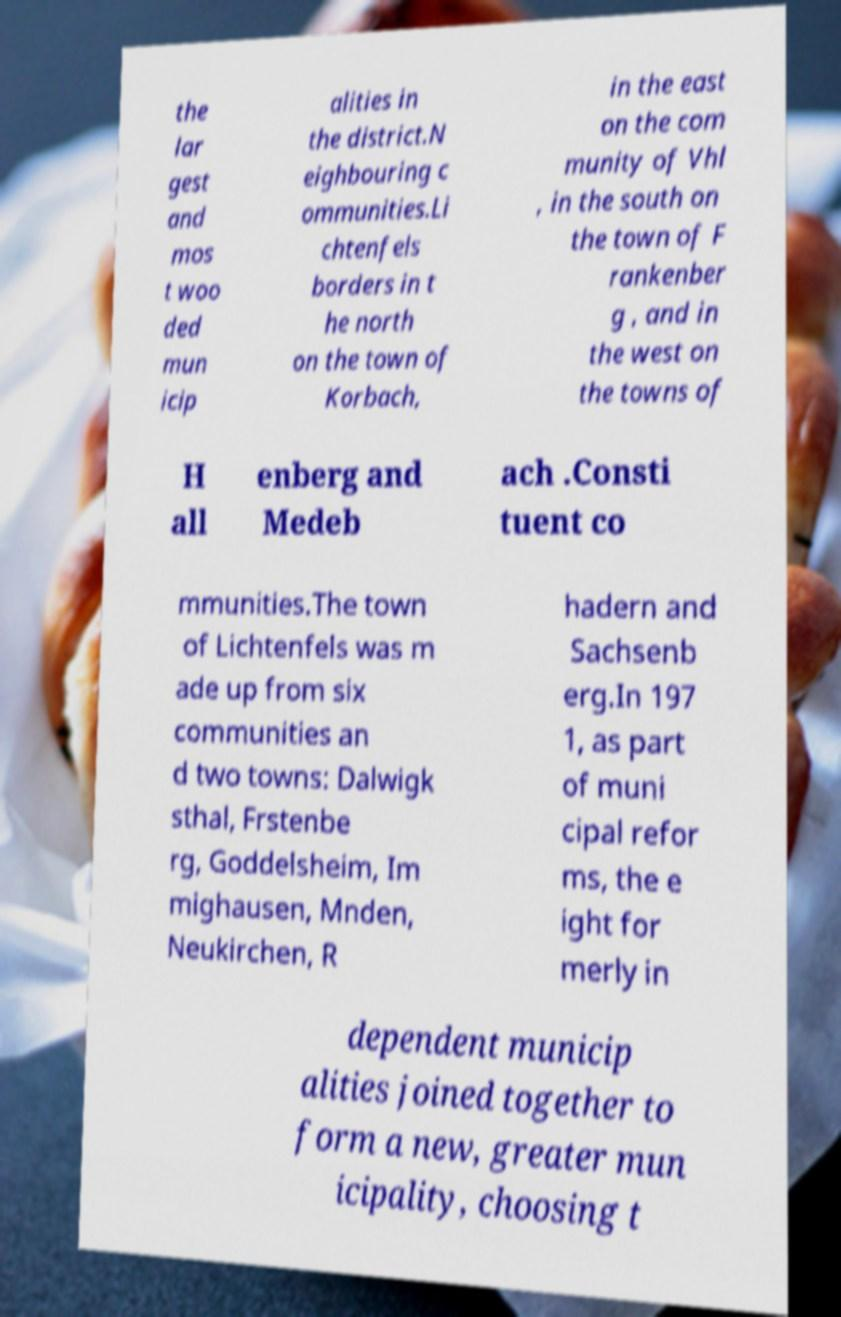Could you assist in decoding the text presented in this image and type it out clearly? the lar gest and mos t woo ded mun icip alities in the district.N eighbouring c ommunities.Li chtenfels borders in t he north on the town of Korbach, in the east on the com munity of Vhl , in the south on the town of F rankenber g , and in the west on the towns of H all enberg and Medeb ach .Consti tuent co mmunities.The town of Lichtenfels was m ade up from six communities an d two towns: Dalwigk sthal, Frstenbe rg, Goddelsheim, Im mighausen, Mnden, Neukirchen, R hadern and Sachsenb erg.In 197 1, as part of muni cipal refor ms, the e ight for merly in dependent municip alities joined together to form a new, greater mun icipality, choosing t 